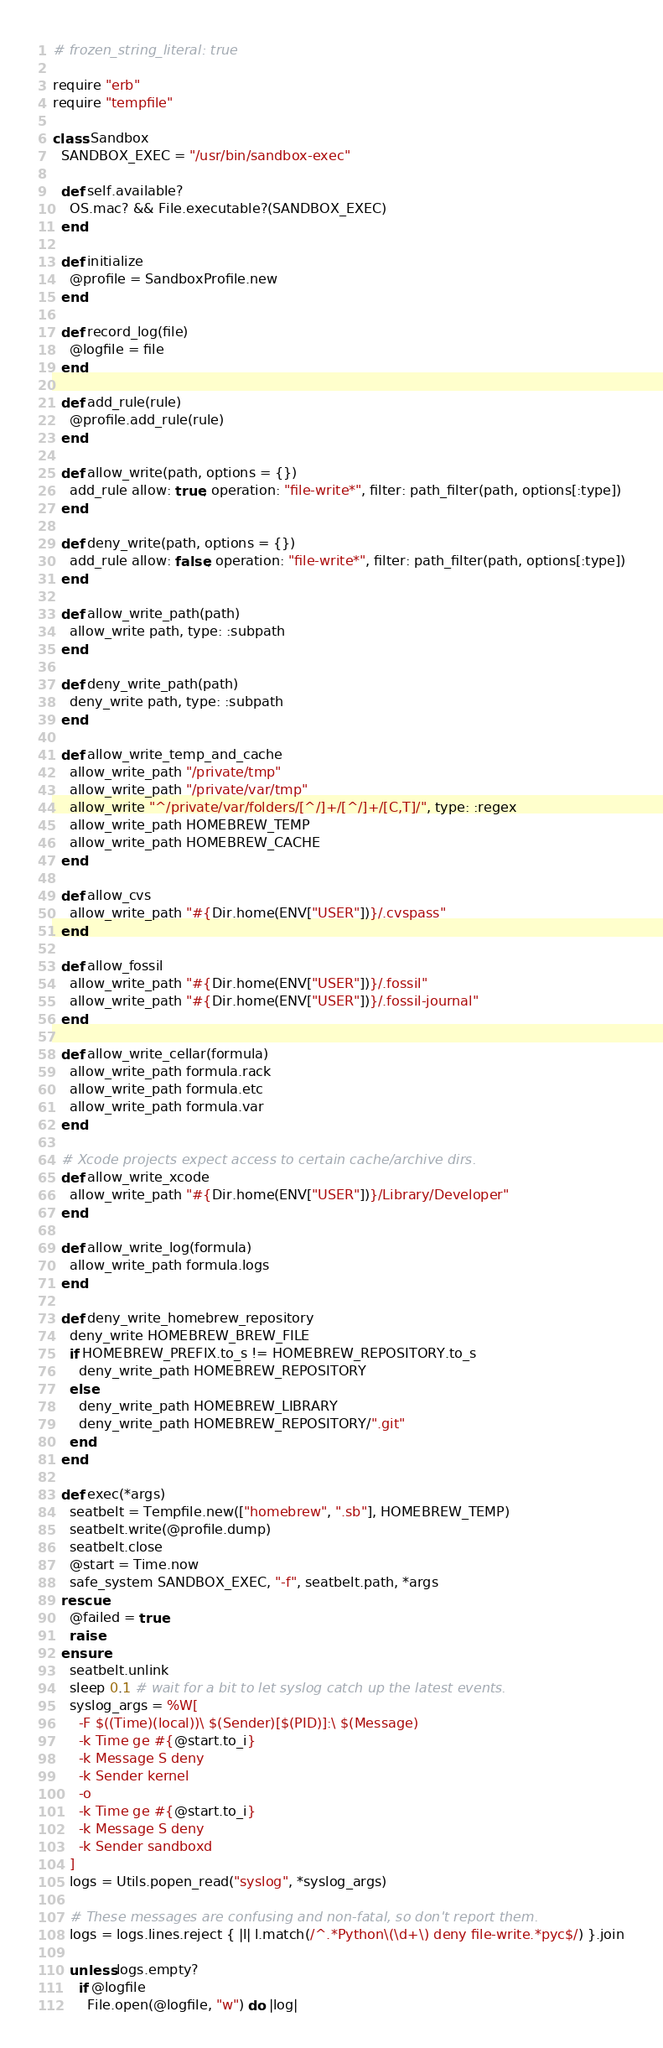Convert code to text. <code><loc_0><loc_0><loc_500><loc_500><_Ruby_># frozen_string_literal: true

require "erb"
require "tempfile"

class Sandbox
  SANDBOX_EXEC = "/usr/bin/sandbox-exec"

  def self.available?
    OS.mac? && File.executable?(SANDBOX_EXEC)
  end

  def initialize
    @profile = SandboxProfile.new
  end

  def record_log(file)
    @logfile = file
  end

  def add_rule(rule)
    @profile.add_rule(rule)
  end

  def allow_write(path, options = {})
    add_rule allow: true, operation: "file-write*", filter: path_filter(path, options[:type])
  end

  def deny_write(path, options = {})
    add_rule allow: false, operation: "file-write*", filter: path_filter(path, options[:type])
  end

  def allow_write_path(path)
    allow_write path, type: :subpath
  end

  def deny_write_path(path)
    deny_write path, type: :subpath
  end

  def allow_write_temp_and_cache
    allow_write_path "/private/tmp"
    allow_write_path "/private/var/tmp"
    allow_write "^/private/var/folders/[^/]+/[^/]+/[C,T]/", type: :regex
    allow_write_path HOMEBREW_TEMP
    allow_write_path HOMEBREW_CACHE
  end

  def allow_cvs
    allow_write_path "#{Dir.home(ENV["USER"])}/.cvspass"
  end

  def allow_fossil
    allow_write_path "#{Dir.home(ENV["USER"])}/.fossil"
    allow_write_path "#{Dir.home(ENV["USER"])}/.fossil-journal"
  end

  def allow_write_cellar(formula)
    allow_write_path formula.rack
    allow_write_path formula.etc
    allow_write_path formula.var
  end

  # Xcode projects expect access to certain cache/archive dirs.
  def allow_write_xcode
    allow_write_path "#{Dir.home(ENV["USER"])}/Library/Developer"
  end

  def allow_write_log(formula)
    allow_write_path formula.logs
  end

  def deny_write_homebrew_repository
    deny_write HOMEBREW_BREW_FILE
    if HOMEBREW_PREFIX.to_s != HOMEBREW_REPOSITORY.to_s
      deny_write_path HOMEBREW_REPOSITORY
    else
      deny_write_path HOMEBREW_LIBRARY
      deny_write_path HOMEBREW_REPOSITORY/".git"
    end
  end

  def exec(*args)
    seatbelt = Tempfile.new(["homebrew", ".sb"], HOMEBREW_TEMP)
    seatbelt.write(@profile.dump)
    seatbelt.close
    @start = Time.now
    safe_system SANDBOX_EXEC, "-f", seatbelt.path, *args
  rescue
    @failed = true
    raise
  ensure
    seatbelt.unlink
    sleep 0.1 # wait for a bit to let syslog catch up the latest events.
    syslog_args = %W[
      -F $((Time)(local))\ $(Sender)[$(PID)]:\ $(Message)
      -k Time ge #{@start.to_i}
      -k Message S deny
      -k Sender kernel
      -o
      -k Time ge #{@start.to_i}
      -k Message S deny
      -k Sender sandboxd
    ]
    logs = Utils.popen_read("syslog", *syslog_args)

    # These messages are confusing and non-fatal, so don't report them.
    logs = logs.lines.reject { |l| l.match(/^.*Python\(\d+\) deny file-write.*pyc$/) }.join

    unless logs.empty?
      if @logfile
        File.open(@logfile, "w") do |log|</code> 